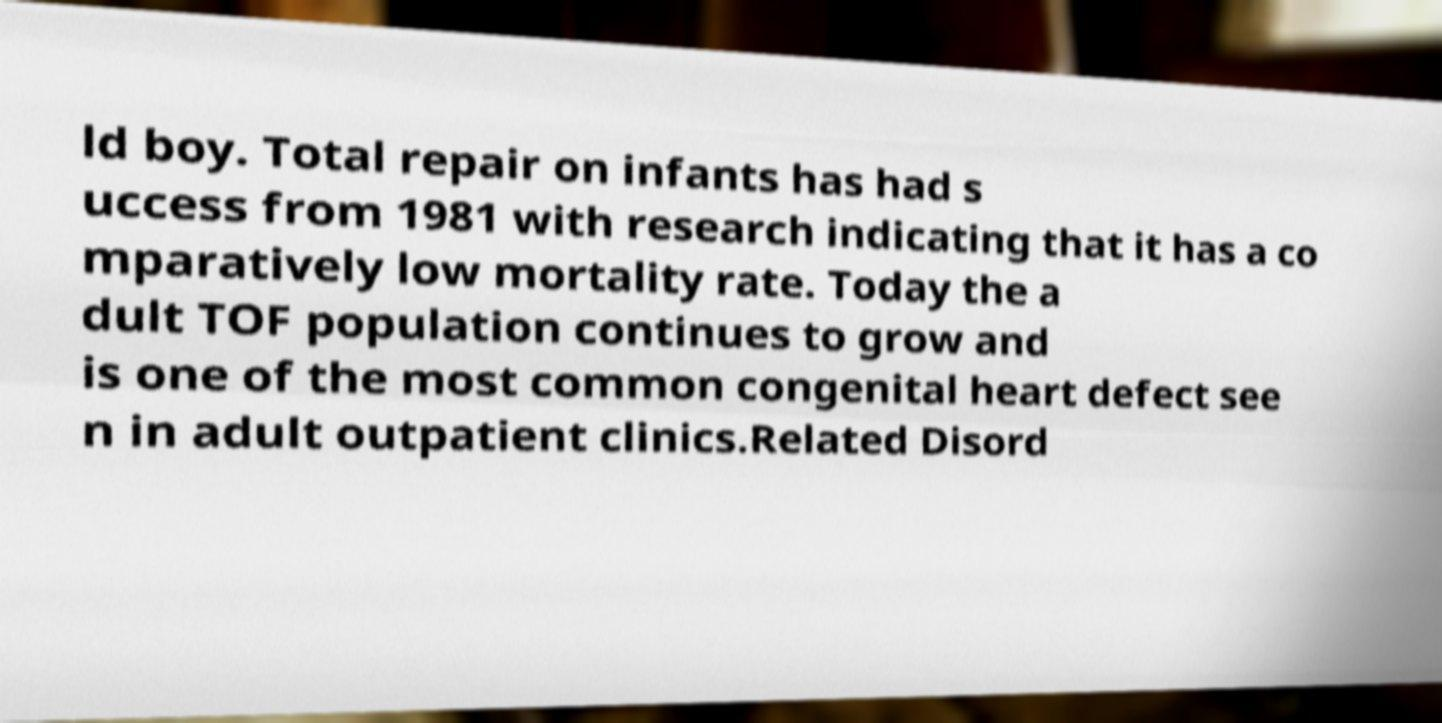I need the written content from this picture converted into text. Can you do that? ld boy. Total repair on infants has had s uccess from 1981 with research indicating that it has a co mparatively low mortality rate. Today the a dult TOF population continues to grow and is one of the most common congenital heart defect see n in adult outpatient clinics.Related Disord 